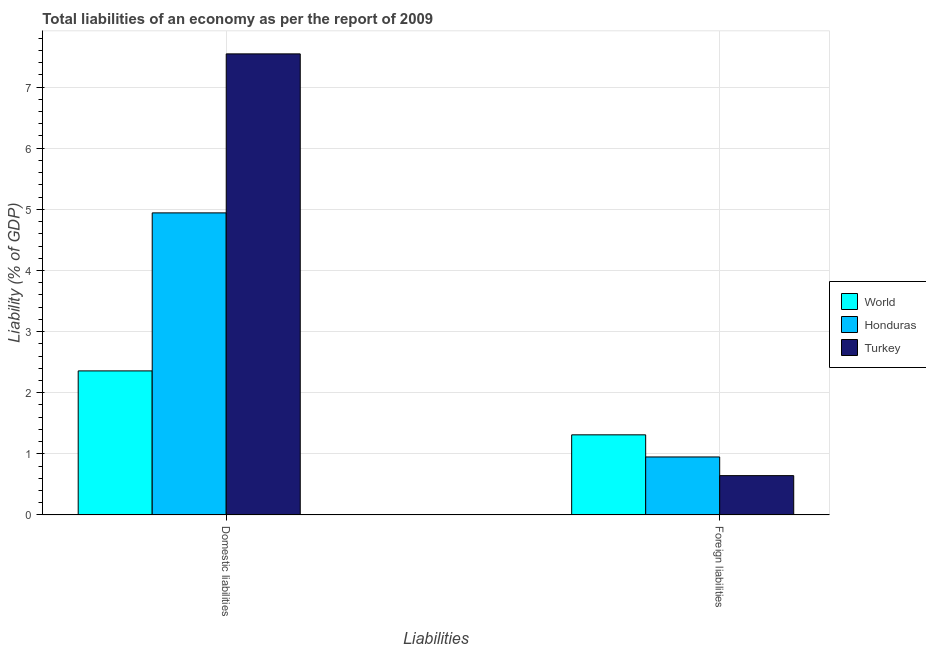How many groups of bars are there?
Your answer should be compact. 2. Are the number of bars on each tick of the X-axis equal?
Provide a short and direct response. Yes. How many bars are there on the 2nd tick from the right?
Your answer should be compact. 3. What is the label of the 2nd group of bars from the left?
Your response must be concise. Foreign liabilities. What is the incurrence of foreign liabilities in World?
Give a very brief answer. 1.31. Across all countries, what is the maximum incurrence of foreign liabilities?
Offer a very short reply. 1.31. Across all countries, what is the minimum incurrence of domestic liabilities?
Offer a very short reply. 2.36. In which country was the incurrence of domestic liabilities maximum?
Your answer should be very brief. Turkey. What is the total incurrence of domestic liabilities in the graph?
Make the answer very short. 14.84. What is the difference between the incurrence of domestic liabilities in Turkey and that in Honduras?
Ensure brevity in your answer.  2.6. What is the difference between the incurrence of foreign liabilities in World and the incurrence of domestic liabilities in Honduras?
Provide a succinct answer. -3.63. What is the average incurrence of domestic liabilities per country?
Your response must be concise. 4.95. What is the difference between the incurrence of domestic liabilities and incurrence of foreign liabilities in Honduras?
Offer a terse response. 3.99. In how many countries, is the incurrence of foreign liabilities greater than 0.2 %?
Make the answer very short. 3. What is the ratio of the incurrence of domestic liabilities in Turkey to that in World?
Make the answer very short. 3.2. In how many countries, is the incurrence of domestic liabilities greater than the average incurrence of domestic liabilities taken over all countries?
Offer a very short reply. 1. What does the 3rd bar from the left in Foreign liabilities represents?
Provide a short and direct response. Turkey. What does the 3rd bar from the right in Domestic liabilities represents?
Your answer should be compact. World. Are the values on the major ticks of Y-axis written in scientific E-notation?
Offer a very short reply. No. What is the title of the graph?
Your answer should be compact. Total liabilities of an economy as per the report of 2009. What is the label or title of the X-axis?
Your answer should be very brief. Liabilities. What is the label or title of the Y-axis?
Offer a very short reply. Liability (% of GDP). What is the Liability (% of GDP) of World in Domestic liabilities?
Make the answer very short. 2.36. What is the Liability (% of GDP) of Honduras in Domestic liabilities?
Your answer should be very brief. 4.94. What is the Liability (% of GDP) in Turkey in Domestic liabilities?
Provide a succinct answer. 7.54. What is the Liability (% of GDP) of World in Foreign liabilities?
Provide a succinct answer. 1.31. What is the Liability (% of GDP) in Honduras in Foreign liabilities?
Your answer should be compact. 0.95. What is the Liability (% of GDP) of Turkey in Foreign liabilities?
Offer a very short reply. 0.64. Across all Liabilities, what is the maximum Liability (% of GDP) in World?
Provide a succinct answer. 2.36. Across all Liabilities, what is the maximum Liability (% of GDP) of Honduras?
Your answer should be compact. 4.94. Across all Liabilities, what is the maximum Liability (% of GDP) in Turkey?
Your answer should be very brief. 7.54. Across all Liabilities, what is the minimum Liability (% of GDP) of World?
Your response must be concise. 1.31. Across all Liabilities, what is the minimum Liability (% of GDP) of Honduras?
Provide a short and direct response. 0.95. Across all Liabilities, what is the minimum Liability (% of GDP) in Turkey?
Offer a very short reply. 0.64. What is the total Liability (% of GDP) of World in the graph?
Give a very brief answer. 3.67. What is the total Liability (% of GDP) of Honduras in the graph?
Provide a succinct answer. 5.89. What is the total Liability (% of GDP) of Turkey in the graph?
Offer a very short reply. 8.19. What is the difference between the Liability (% of GDP) in World in Domestic liabilities and that in Foreign liabilities?
Make the answer very short. 1.05. What is the difference between the Liability (% of GDP) of Honduras in Domestic liabilities and that in Foreign liabilities?
Keep it short and to the point. 3.99. What is the difference between the Liability (% of GDP) of Turkey in Domestic liabilities and that in Foreign liabilities?
Offer a very short reply. 6.9. What is the difference between the Liability (% of GDP) of World in Domestic liabilities and the Liability (% of GDP) of Honduras in Foreign liabilities?
Make the answer very short. 1.41. What is the difference between the Liability (% of GDP) in World in Domestic liabilities and the Liability (% of GDP) in Turkey in Foreign liabilities?
Offer a very short reply. 1.71. What is the difference between the Liability (% of GDP) of Honduras in Domestic liabilities and the Liability (% of GDP) of Turkey in Foreign liabilities?
Keep it short and to the point. 4.3. What is the average Liability (% of GDP) of World per Liabilities?
Offer a terse response. 1.83. What is the average Liability (% of GDP) of Honduras per Liabilities?
Your response must be concise. 2.95. What is the average Liability (% of GDP) of Turkey per Liabilities?
Give a very brief answer. 4.09. What is the difference between the Liability (% of GDP) of World and Liability (% of GDP) of Honduras in Domestic liabilities?
Your answer should be compact. -2.59. What is the difference between the Liability (% of GDP) in World and Liability (% of GDP) in Turkey in Domestic liabilities?
Give a very brief answer. -5.19. What is the difference between the Liability (% of GDP) of Honduras and Liability (% of GDP) of Turkey in Domestic liabilities?
Offer a very short reply. -2.6. What is the difference between the Liability (% of GDP) in World and Liability (% of GDP) in Honduras in Foreign liabilities?
Your answer should be compact. 0.36. What is the difference between the Liability (% of GDP) of World and Liability (% of GDP) of Turkey in Foreign liabilities?
Your answer should be very brief. 0.67. What is the difference between the Liability (% of GDP) of Honduras and Liability (% of GDP) of Turkey in Foreign liabilities?
Give a very brief answer. 0.31. What is the ratio of the Liability (% of GDP) in World in Domestic liabilities to that in Foreign liabilities?
Offer a terse response. 1.8. What is the ratio of the Liability (% of GDP) in Honduras in Domestic liabilities to that in Foreign liabilities?
Give a very brief answer. 5.21. What is the ratio of the Liability (% of GDP) in Turkey in Domestic liabilities to that in Foreign liabilities?
Make the answer very short. 11.73. What is the difference between the highest and the second highest Liability (% of GDP) of World?
Your answer should be very brief. 1.05. What is the difference between the highest and the second highest Liability (% of GDP) of Honduras?
Your answer should be very brief. 3.99. What is the difference between the highest and the second highest Liability (% of GDP) of Turkey?
Keep it short and to the point. 6.9. What is the difference between the highest and the lowest Liability (% of GDP) in World?
Your response must be concise. 1.05. What is the difference between the highest and the lowest Liability (% of GDP) of Honduras?
Keep it short and to the point. 3.99. What is the difference between the highest and the lowest Liability (% of GDP) of Turkey?
Ensure brevity in your answer.  6.9. 